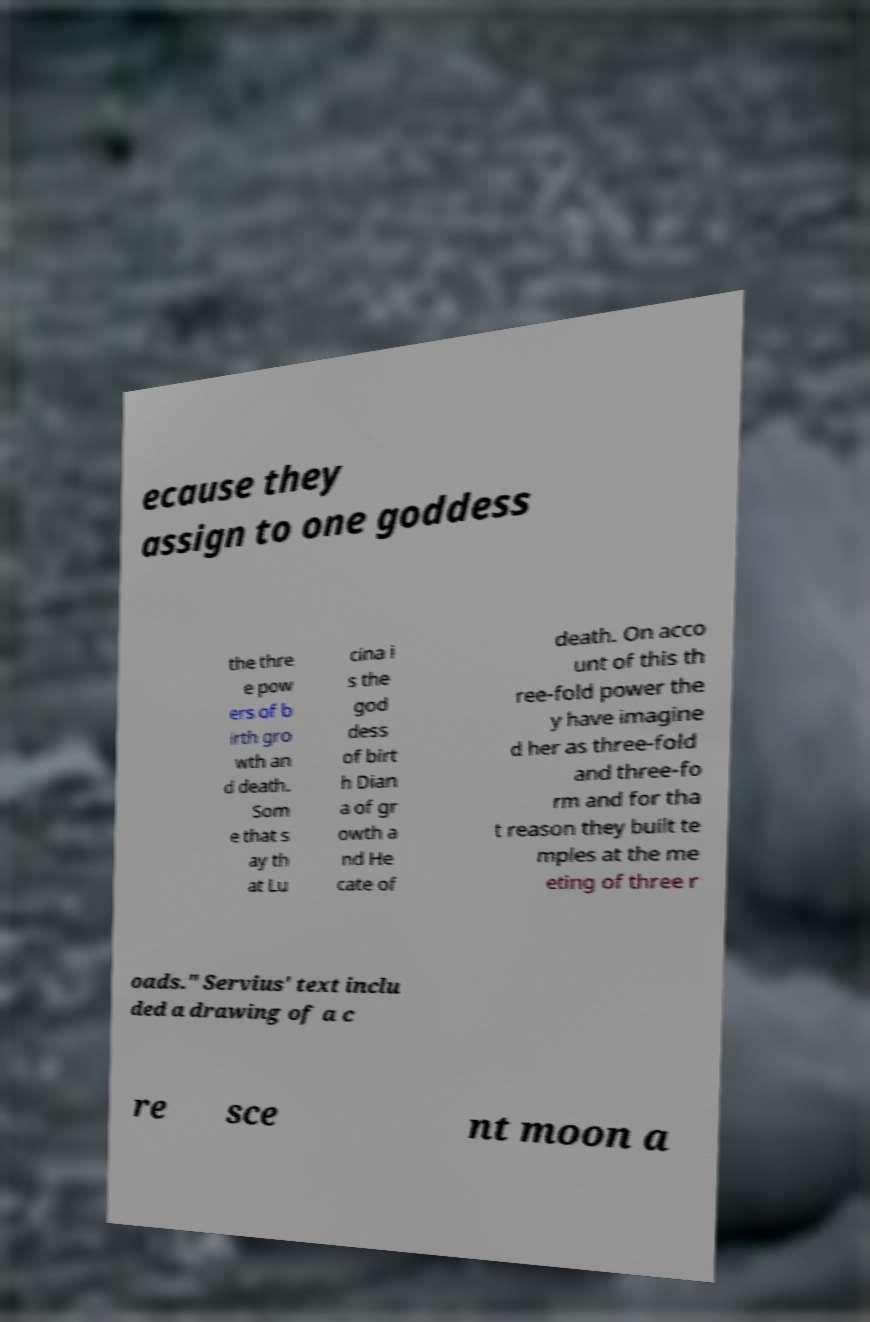Please identify and transcribe the text found in this image. ecause they assign to one goddess the thre e pow ers of b irth gro wth an d death. Som e that s ay th at Lu cina i s the god dess of birt h Dian a of gr owth a nd He cate of death. On acco unt of this th ree-fold power the y have imagine d her as three-fold and three-fo rm and for tha t reason they built te mples at the me eting of three r oads." Servius' text inclu ded a drawing of a c re sce nt moon a 